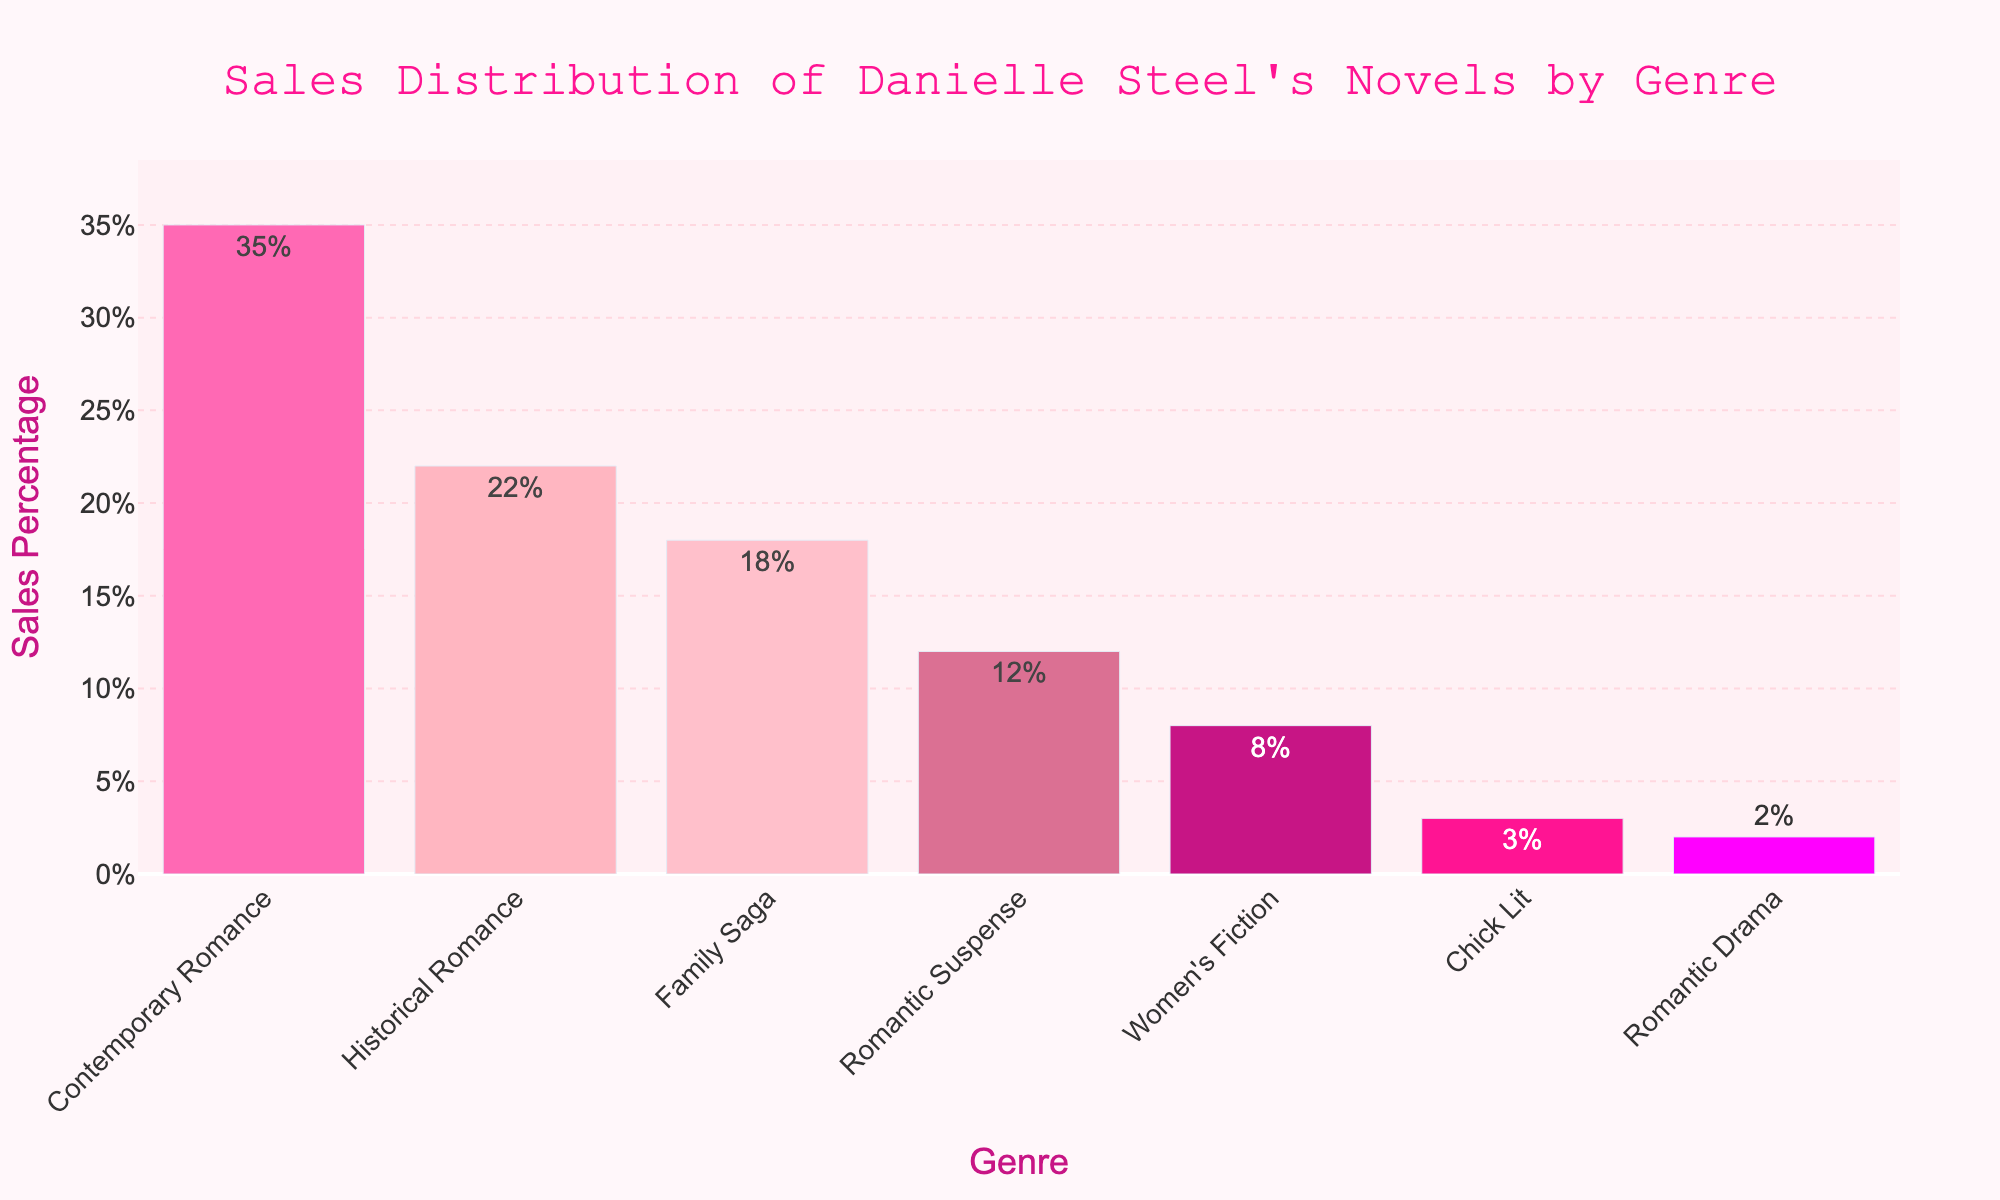What genre has the highest sales percentage? The highest bar represents the genre with the highest sales percentage, which is "Contemporary Romance" at 35%.
Answer: Contemporary Romance How much higher is the sales percentage of Contemporary Romance compared to Romantic Suspense? Subtract the sales percentage of Romantic Suspense (12%) from Contemporary Romance (35%): 35% - 12% = 23%.
Answer: 23% Which genre has the lowest sales percentage, and what is it? The shortest bar corresponds to the lowest sales percentage, which is "Romantic Drama" at 2%.
Answer: Romantic Drama What's the total sales percentage for Historical Romance and Family Saga combined? Add the sales percentages of Historical Romance (22%) and Family Saga (18%): 22% + 18% = 40%.
Answer: 40% Rank the genres from highest to lowest sales percentage. Based on the heights of the bars from highest to lowest: Contemporary Romance (35%), Historical Romance (22%), Family Saga (18%), Romantic Suspense (12%), Women's Fiction (8%), Chick Lit (3%), and Romantic Drama (2%).
Answer: Contemporary Romance, Historical Romance, Family Saga, Romantic Suspense, Women's Fiction, Chick Lit, Romantic Drama Is the sales percentage of Women's Fiction closer to that of Romantic Suspense or Chick Lit? Calculate the differences: Women's Fiction (8%) to Romantic Suspense (12%) is 4%, and Women's Fiction (8%) to Chick Lit (3%) is 5%. Therefore, 8% is closer to 12% than to 3%.
Answer: Romantic Suspense What is the average sales percentage of all the genres combined? Sum all the percentages (35% + 22% + 18% + 12% + 8% + 3% + 2% = 100%) and divide by the number of genres (7): 100% / 7 ≈ 14.29%.
Answer: 14.29% By how much is the sales percentage of Family Saga greater than that of Women's Fiction? Subtract the sales percentage of Women's Fiction (8%) from Family Saga (18%): 18% - 8% = 10%.
Answer: 10% What percentage of the total sales do the three least popular genres contribute? Sum the sales percentages of Romantic Suspense (12%), Chick Lit (3%), and Romantic Drama (2%): 12% + 3% + 2% = 17%.
Answer: 17% What is the color used for the bar representing Historical Romance? The bar for Historical Romance is second tallest and its color corresponds to a pink shade appearing second in order from the left starting with a dark pink. This color is light pink.
Answer: Light pink 